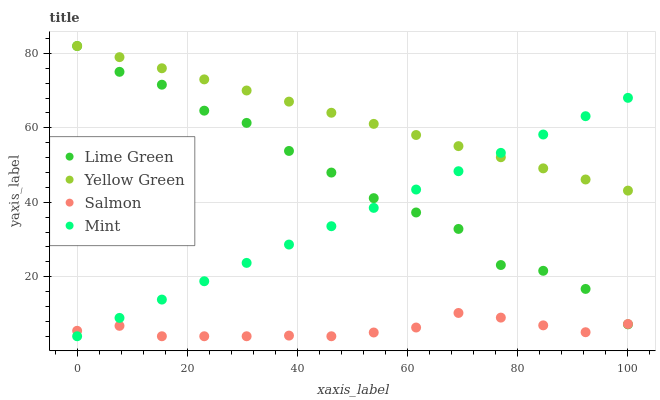Does Salmon have the minimum area under the curve?
Answer yes or no. Yes. Does Yellow Green have the maximum area under the curve?
Answer yes or no. Yes. Does Mint have the minimum area under the curve?
Answer yes or no. No. Does Mint have the maximum area under the curve?
Answer yes or no. No. Is Mint the smoothest?
Answer yes or no. Yes. Is Lime Green the roughest?
Answer yes or no. Yes. Is Lime Green the smoothest?
Answer yes or no. No. Is Mint the roughest?
Answer yes or no. No. Does Salmon have the lowest value?
Answer yes or no. Yes. Does Lime Green have the lowest value?
Answer yes or no. No. Does Yellow Green have the highest value?
Answer yes or no. Yes. Does Mint have the highest value?
Answer yes or no. No. Is Salmon less than Yellow Green?
Answer yes or no. Yes. Is Yellow Green greater than Salmon?
Answer yes or no. Yes. Does Lime Green intersect Yellow Green?
Answer yes or no. Yes. Is Lime Green less than Yellow Green?
Answer yes or no. No. Is Lime Green greater than Yellow Green?
Answer yes or no. No. Does Salmon intersect Yellow Green?
Answer yes or no. No. 